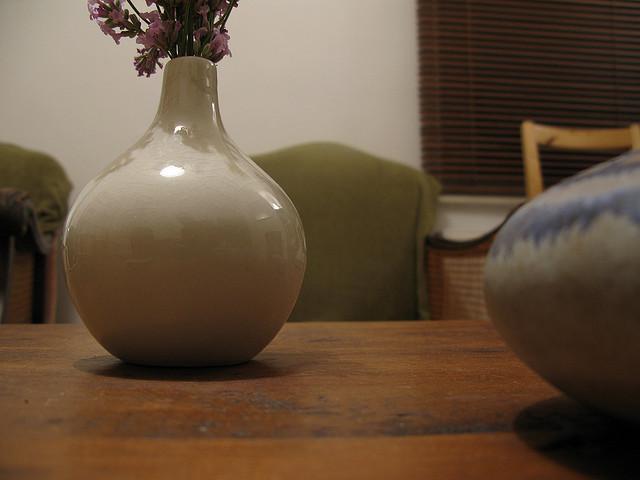How many flower pots are there?
Give a very brief answer. 1. How many vases are in the picture?
Give a very brief answer. 2. How many chairs can you see?
Give a very brief answer. 3. How many reflected cat eyes are pictured?
Give a very brief answer. 0. 